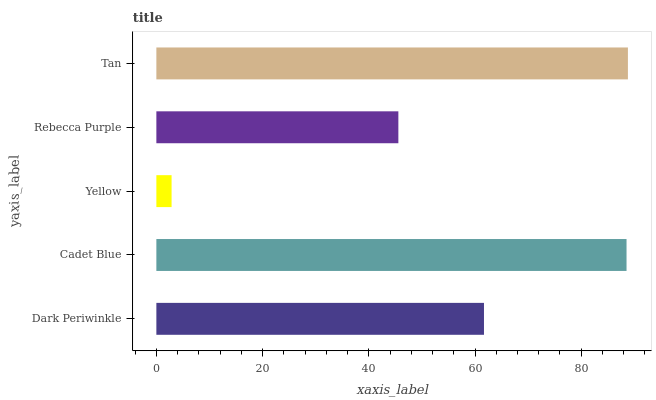Is Yellow the minimum?
Answer yes or no. Yes. Is Tan the maximum?
Answer yes or no. Yes. Is Cadet Blue the minimum?
Answer yes or no. No. Is Cadet Blue the maximum?
Answer yes or no. No. Is Cadet Blue greater than Dark Periwinkle?
Answer yes or no. Yes. Is Dark Periwinkle less than Cadet Blue?
Answer yes or no. Yes. Is Dark Periwinkle greater than Cadet Blue?
Answer yes or no. No. Is Cadet Blue less than Dark Periwinkle?
Answer yes or no. No. Is Dark Periwinkle the high median?
Answer yes or no. Yes. Is Dark Periwinkle the low median?
Answer yes or no. Yes. Is Tan the high median?
Answer yes or no. No. Is Rebecca Purple the low median?
Answer yes or no. No. 